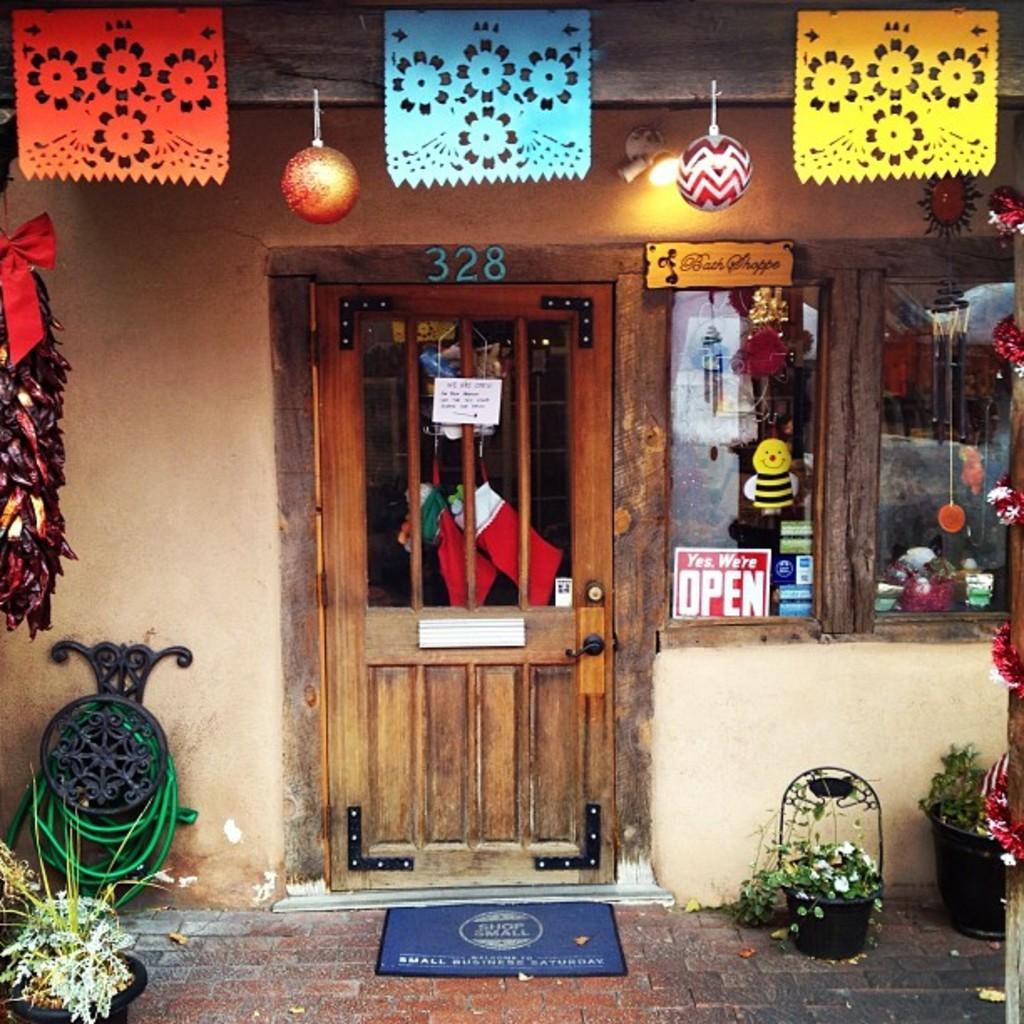Describe this image in one or two sentences. In this image I can see a stall, I can also see few lights and few colorful papers. Background I can see few glass windows, plants in green color and I can also see flowers in white color, and I can also see few decorative items. 